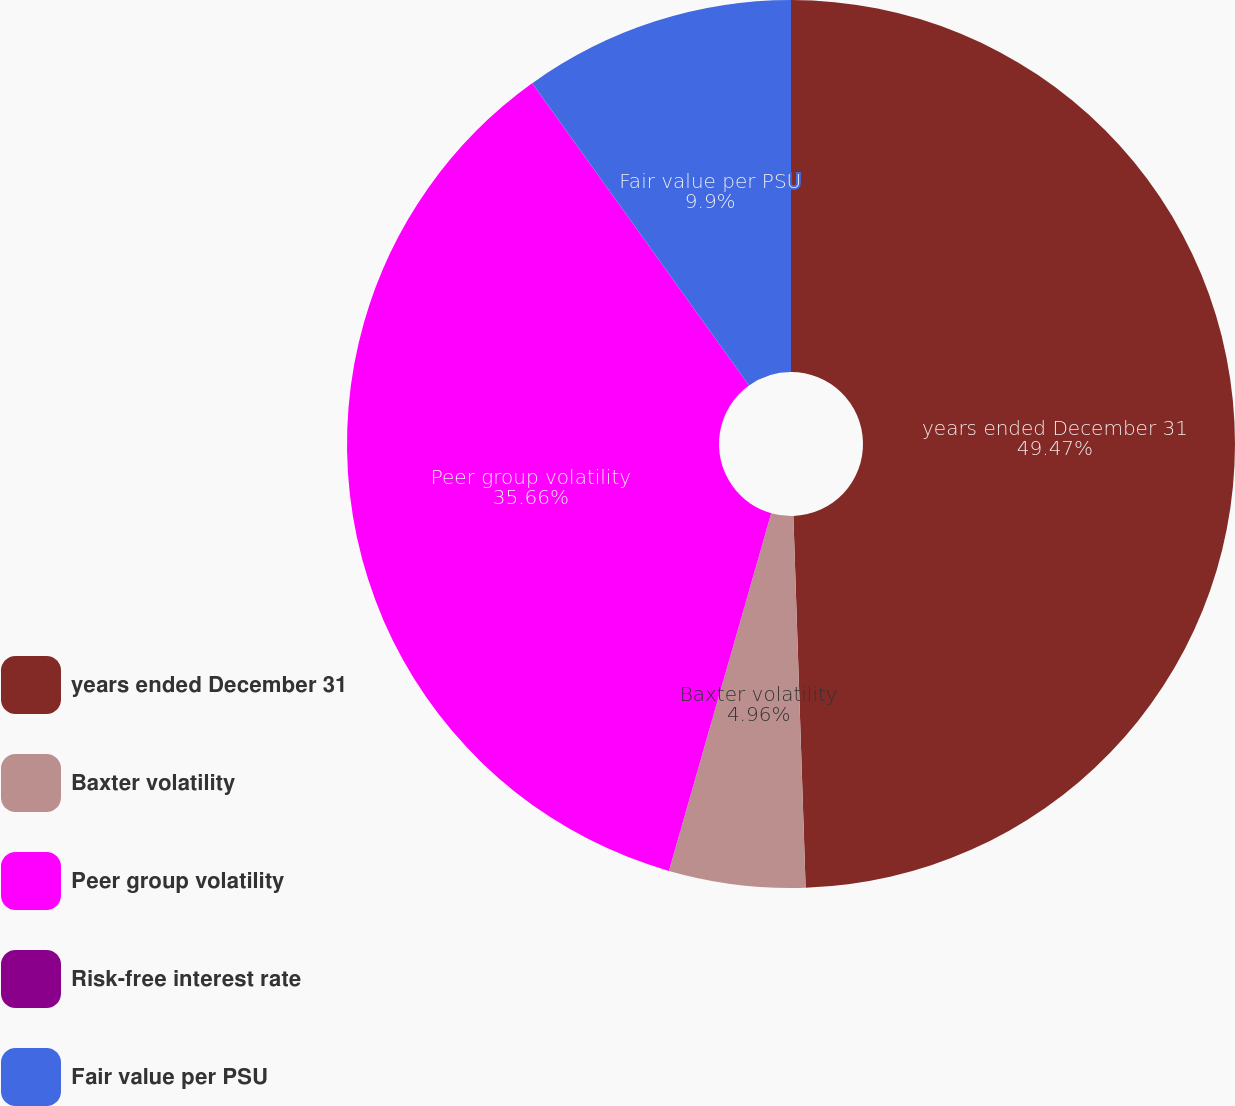Convert chart to OTSL. <chart><loc_0><loc_0><loc_500><loc_500><pie_chart><fcel>years ended December 31<fcel>Baxter volatility<fcel>Peer group volatility<fcel>Risk-free interest rate<fcel>Fair value per PSU<nl><fcel>49.48%<fcel>4.96%<fcel>35.66%<fcel>0.01%<fcel>9.9%<nl></chart> 